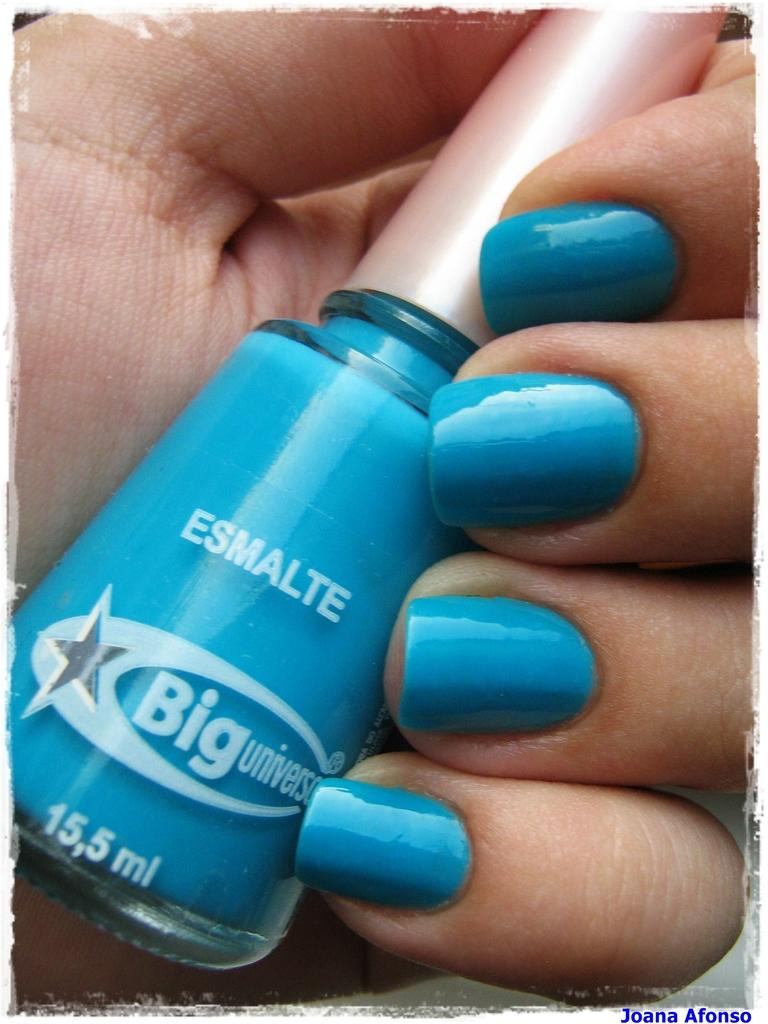Who or what is the main subject in the image? There is a person in the image. What part of the person's body can be seen in the image? The person's hand is visible in the image. What is the person holding in their hand? The person is holding a blue color nail-polish in their hand. What type of sign can be seen in the background of the image? There is no sign visible in the background of the image. What kind of pest is crawling on the person's hand in the image? There are no pests present on the person's hand in the image. 